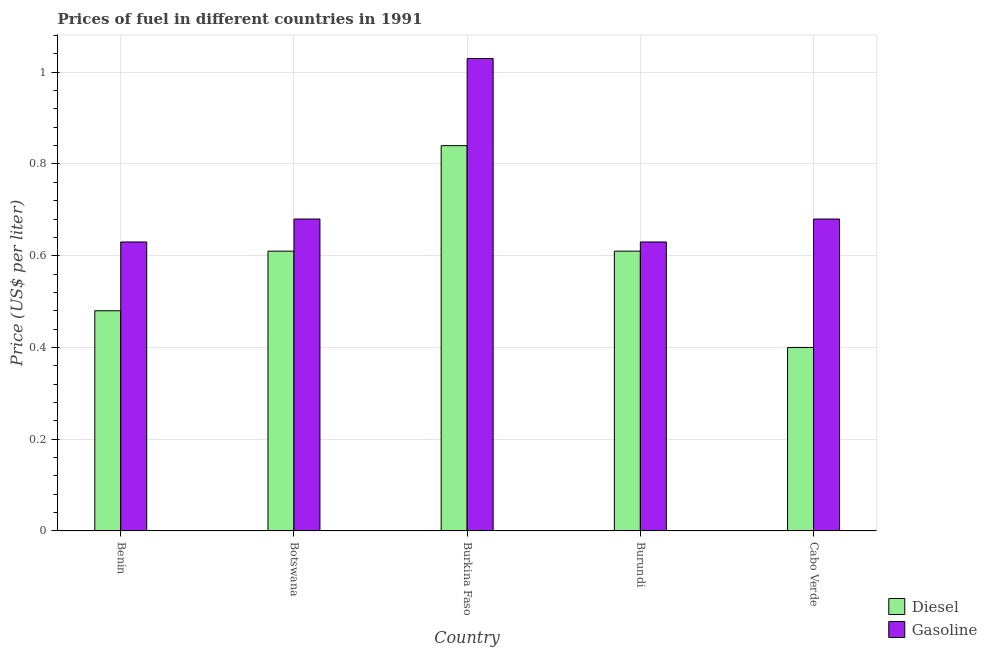How many groups of bars are there?
Give a very brief answer. 5. What is the label of the 1st group of bars from the left?
Your response must be concise. Benin. In how many cases, is the number of bars for a given country not equal to the number of legend labels?
Your answer should be compact. 0. What is the gasoline price in Burundi?
Give a very brief answer. 0.63. In which country was the gasoline price maximum?
Offer a terse response. Burkina Faso. In which country was the diesel price minimum?
Your answer should be very brief. Cabo Verde. What is the total diesel price in the graph?
Offer a terse response. 2.94. What is the difference between the diesel price in Benin and that in Burkina Faso?
Offer a very short reply. -0.36. What is the difference between the diesel price in Botswana and the gasoline price in Cabo Verde?
Offer a terse response. -0.07. What is the average diesel price per country?
Your answer should be very brief. 0.59. What is the difference between the diesel price and gasoline price in Burkina Faso?
Your answer should be very brief. -0.19. What is the ratio of the gasoline price in Botswana to that in Burkina Faso?
Offer a very short reply. 0.66. Is the diesel price in Botswana less than that in Cabo Verde?
Provide a short and direct response. No. What is the difference between the highest and the lowest diesel price?
Ensure brevity in your answer.  0.44. What does the 2nd bar from the left in Botswana represents?
Offer a terse response. Gasoline. What does the 1st bar from the right in Botswana represents?
Your response must be concise. Gasoline. What is the difference between two consecutive major ticks on the Y-axis?
Offer a terse response. 0.2. Does the graph contain any zero values?
Your response must be concise. No. Where does the legend appear in the graph?
Provide a short and direct response. Bottom right. How many legend labels are there?
Make the answer very short. 2. What is the title of the graph?
Make the answer very short. Prices of fuel in different countries in 1991. Does "RDB nonconcessional" appear as one of the legend labels in the graph?
Offer a very short reply. No. What is the label or title of the X-axis?
Offer a terse response. Country. What is the label or title of the Y-axis?
Your answer should be very brief. Price (US$ per liter). What is the Price (US$ per liter) of Diesel in Benin?
Offer a terse response. 0.48. What is the Price (US$ per liter) in Gasoline in Benin?
Provide a succinct answer. 0.63. What is the Price (US$ per liter) of Diesel in Botswana?
Provide a succinct answer. 0.61. What is the Price (US$ per liter) of Gasoline in Botswana?
Your answer should be compact. 0.68. What is the Price (US$ per liter) in Diesel in Burkina Faso?
Your answer should be very brief. 0.84. What is the Price (US$ per liter) of Diesel in Burundi?
Your response must be concise. 0.61. What is the Price (US$ per liter) of Gasoline in Burundi?
Provide a succinct answer. 0.63. What is the Price (US$ per liter) in Gasoline in Cabo Verde?
Ensure brevity in your answer.  0.68. Across all countries, what is the maximum Price (US$ per liter) of Diesel?
Your answer should be very brief. 0.84. Across all countries, what is the maximum Price (US$ per liter) in Gasoline?
Provide a short and direct response. 1.03. Across all countries, what is the minimum Price (US$ per liter) in Gasoline?
Provide a succinct answer. 0.63. What is the total Price (US$ per liter) of Diesel in the graph?
Your answer should be compact. 2.94. What is the total Price (US$ per liter) in Gasoline in the graph?
Make the answer very short. 3.65. What is the difference between the Price (US$ per liter) in Diesel in Benin and that in Botswana?
Offer a very short reply. -0.13. What is the difference between the Price (US$ per liter) in Diesel in Benin and that in Burkina Faso?
Make the answer very short. -0.36. What is the difference between the Price (US$ per liter) of Diesel in Benin and that in Burundi?
Give a very brief answer. -0.13. What is the difference between the Price (US$ per liter) of Gasoline in Benin and that in Burundi?
Offer a terse response. 0. What is the difference between the Price (US$ per liter) of Diesel in Botswana and that in Burkina Faso?
Your answer should be very brief. -0.23. What is the difference between the Price (US$ per liter) in Gasoline in Botswana and that in Burkina Faso?
Offer a very short reply. -0.35. What is the difference between the Price (US$ per liter) in Diesel in Botswana and that in Burundi?
Keep it short and to the point. 0. What is the difference between the Price (US$ per liter) in Diesel in Botswana and that in Cabo Verde?
Keep it short and to the point. 0.21. What is the difference between the Price (US$ per liter) in Diesel in Burkina Faso and that in Burundi?
Ensure brevity in your answer.  0.23. What is the difference between the Price (US$ per liter) in Gasoline in Burkina Faso and that in Burundi?
Provide a short and direct response. 0.4. What is the difference between the Price (US$ per liter) in Diesel in Burkina Faso and that in Cabo Verde?
Provide a short and direct response. 0.44. What is the difference between the Price (US$ per liter) in Diesel in Burundi and that in Cabo Verde?
Ensure brevity in your answer.  0.21. What is the difference between the Price (US$ per liter) in Diesel in Benin and the Price (US$ per liter) in Gasoline in Burkina Faso?
Offer a very short reply. -0.55. What is the difference between the Price (US$ per liter) in Diesel in Benin and the Price (US$ per liter) in Gasoline in Burundi?
Keep it short and to the point. -0.15. What is the difference between the Price (US$ per liter) in Diesel in Benin and the Price (US$ per liter) in Gasoline in Cabo Verde?
Your answer should be compact. -0.2. What is the difference between the Price (US$ per liter) in Diesel in Botswana and the Price (US$ per liter) in Gasoline in Burkina Faso?
Offer a very short reply. -0.42. What is the difference between the Price (US$ per liter) of Diesel in Botswana and the Price (US$ per liter) of Gasoline in Burundi?
Keep it short and to the point. -0.02. What is the difference between the Price (US$ per liter) of Diesel in Botswana and the Price (US$ per liter) of Gasoline in Cabo Verde?
Offer a terse response. -0.07. What is the difference between the Price (US$ per liter) of Diesel in Burkina Faso and the Price (US$ per liter) of Gasoline in Burundi?
Give a very brief answer. 0.21. What is the difference between the Price (US$ per liter) of Diesel in Burkina Faso and the Price (US$ per liter) of Gasoline in Cabo Verde?
Make the answer very short. 0.16. What is the difference between the Price (US$ per liter) in Diesel in Burundi and the Price (US$ per liter) in Gasoline in Cabo Verde?
Provide a short and direct response. -0.07. What is the average Price (US$ per liter) of Diesel per country?
Keep it short and to the point. 0.59. What is the average Price (US$ per liter) in Gasoline per country?
Provide a succinct answer. 0.73. What is the difference between the Price (US$ per liter) in Diesel and Price (US$ per liter) in Gasoline in Benin?
Your response must be concise. -0.15. What is the difference between the Price (US$ per liter) in Diesel and Price (US$ per liter) in Gasoline in Botswana?
Your answer should be very brief. -0.07. What is the difference between the Price (US$ per liter) of Diesel and Price (US$ per liter) of Gasoline in Burkina Faso?
Your response must be concise. -0.19. What is the difference between the Price (US$ per liter) in Diesel and Price (US$ per liter) in Gasoline in Burundi?
Provide a short and direct response. -0.02. What is the difference between the Price (US$ per liter) of Diesel and Price (US$ per liter) of Gasoline in Cabo Verde?
Ensure brevity in your answer.  -0.28. What is the ratio of the Price (US$ per liter) in Diesel in Benin to that in Botswana?
Your answer should be very brief. 0.79. What is the ratio of the Price (US$ per liter) in Gasoline in Benin to that in Botswana?
Provide a succinct answer. 0.93. What is the ratio of the Price (US$ per liter) in Diesel in Benin to that in Burkina Faso?
Your answer should be very brief. 0.57. What is the ratio of the Price (US$ per liter) of Gasoline in Benin to that in Burkina Faso?
Provide a short and direct response. 0.61. What is the ratio of the Price (US$ per liter) of Diesel in Benin to that in Burundi?
Ensure brevity in your answer.  0.79. What is the ratio of the Price (US$ per liter) in Gasoline in Benin to that in Burundi?
Keep it short and to the point. 1. What is the ratio of the Price (US$ per liter) of Gasoline in Benin to that in Cabo Verde?
Provide a short and direct response. 0.93. What is the ratio of the Price (US$ per liter) of Diesel in Botswana to that in Burkina Faso?
Your response must be concise. 0.73. What is the ratio of the Price (US$ per liter) of Gasoline in Botswana to that in Burkina Faso?
Your answer should be very brief. 0.66. What is the ratio of the Price (US$ per liter) in Diesel in Botswana to that in Burundi?
Offer a terse response. 1. What is the ratio of the Price (US$ per liter) of Gasoline in Botswana to that in Burundi?
Your answer should be very brief. 1.08. What is the ratio of the Price (US$ per liter) in Diesel in Botswana to that in Cabo Verde?
Keep it short and to the point. 1.52. What is the ratio of the Price (US$ per liter) of Gasoline in Botswana to that in Cabo Verde?
Provide a succinct answer. 1. What is the ratio of the Price (US$ per liter) of Diesel in Burkina Faso to that in Burundi?
Provide a short and direct response. 1.38. What is the ratio of the Price (US$ per liter) of Gasoline in Burkina Faso to that in Burundi?
Your answer should be compact. 1.63. What is the ratio of the Price (US$ per liter) in Diesel in Burkina Faso to that in Cabo Verde?
Your response must be concise. 2.1. What is the ratio of the Price (US$ per liter) of Gasoline in Burkina Faso to that in Cabo Verde?
Make the answer very short. 1.51. What is the ratio of the Price (US$ per liter) of Diesel in Burundi to that in Cabo Verde?
Your answer should be very brief. 1.52. What is the ratio of the Price (US$ per liter) in Gasoline in Burundi to that in Cabo Verde?
Give a very brief answer. 0.93. What is the difference between the highest and the second highest Price (US$ per liter) of Diesel?
Your answer should be very brief. 0.23. What is the difference between the highest and the lowest Price (US$ per liter) of Diesel?
Provide a succinct answer. 0.44. 